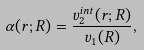Convert formula to latex. <formula><loc_0><loc_0><loc_500><loc_500>\alpha ( { r } ; { R } ) = \frac { v _ { 2 } ^ { i n t } ( { r } ; { R } ) } { v _ { 1 } ( { R } ) } ,</formula> 